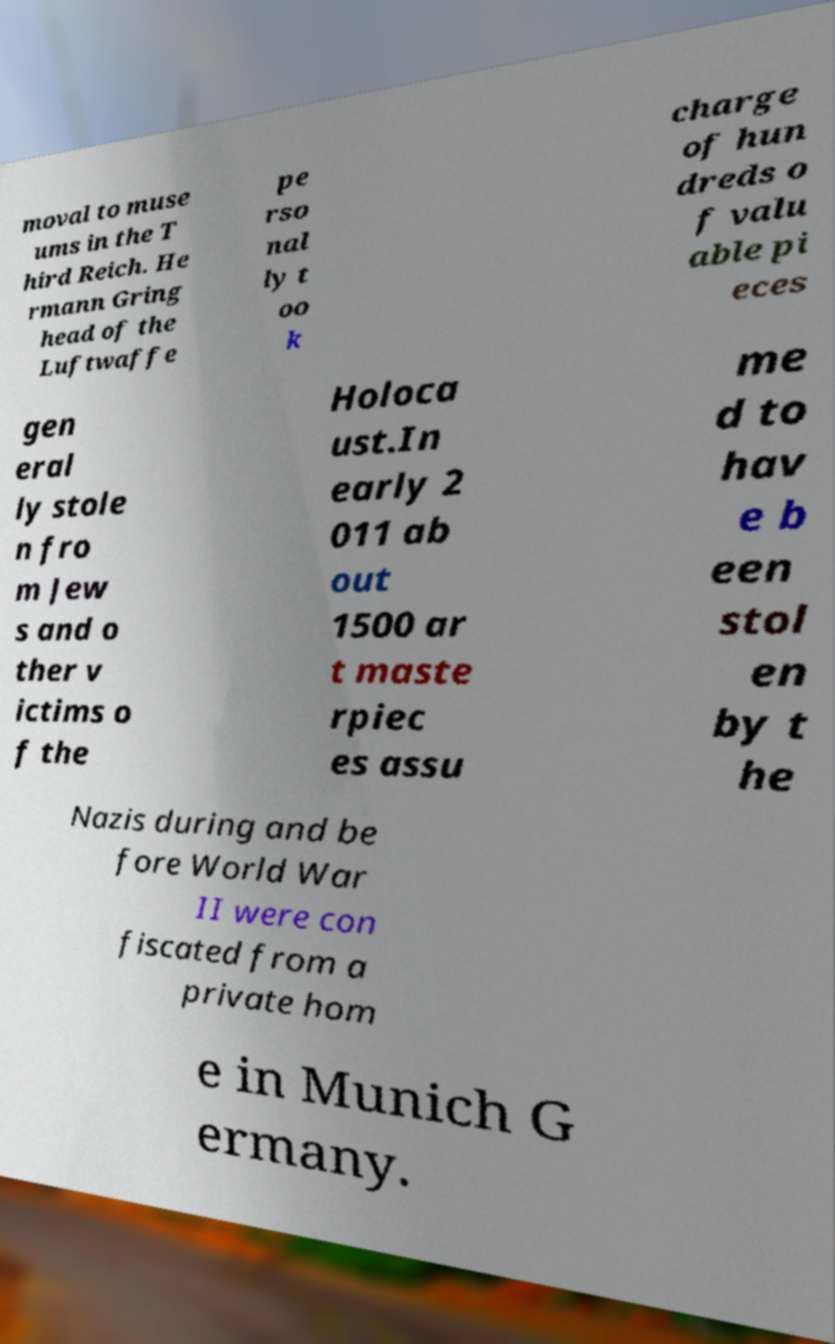Could you extract and type out the text from this image? moval to muse ums in the T hird Reich. He rmann Gring head of the Luftwaffe pe rso nal ly t oo k charge of hun dreds o f valu able pi eces gen eral ly stole n fro m Jew s and o ther v ictims o f the Holoca ust.In early 2 011 ab out 1500 ar t maste rpiec es assu me d to hav e b een stol en by t he Nazis during and be fore World War II were con fiscated from a private hom e in Munich G ermany. 